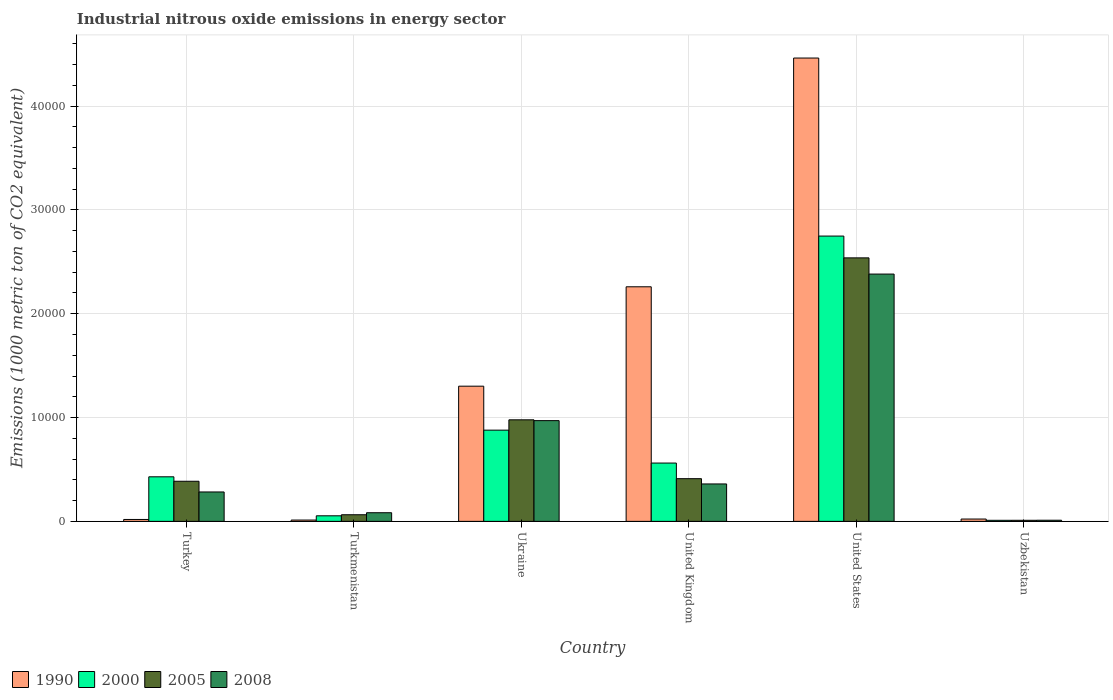How many different coloured bars are there?
Your answer should be very brief. 4. How many groups of bars are there?
Keep it short and to the point. 6. How many bars are there on the 6th tick from the right?
Provide a succinct answer. 4. What is the label of the 6th group of bars from the left?
Keep it short and to the point. Uzbekistan. In how many cases, is the number of bars for a given country not equal to the number of legend labels?
Provide a succinct answer. 0. What is the amount of industrial nitrous oxide emitted in 2000 in United States?
Your answer should be compact. 2.75e+04. Across all countries, what is the maximum amount of industrial nitrous oxide emitted in 2000?
Your response must be concise. 2.75e+04. Across all countries, what is the minimum amount of industrial nitrous oxide emitted in 2005?
Ensure brevity in your answer.  103.2. In which country was the amount of industrial nitrous oxide emitted in 2005 minimum?
Provide a short and direct response. Uzbekistan. What is the total amount of industrial nitrous oxide emitted in 2005 in the graph?
Make the answer very short. 4.39e+04. What is the difference between the amount of industrial nitrous oxide emitted in 2008 in Ukraine and that in United States?
Provide a succinct answer. -1.41e+04. What is the difference between the amount of industrial nitrous oxide emitted in 2005 in Ukraine and the amount of industrial nitrous oxide emitted in 1990 in United States?
Offer a very short reply. -3.48e+04. What is the average amount of industrial nitrous oxide emitted in 2000 per country?
Give a very brief answer. 7801.33. What is the difference between the amount of industrial nitrous oxide emitted of/in 1990 and amount of industrial nitrous oxide emitted of/in 2008 in Turkmenistan?
Your response must be concise. -706.9. What is the ratio of the amount of industrial nitrous oxide emitted in 2005 in United Kingdom to that in United States?
Give a very brief answer. 0.16. Is the amount of industrial nitrous oxide emitted in 2000 in Turkey less than that in Turkmenistan?
Keep it short and to the point. No. Is the difference between the amount of industrial nitrous oxide emitted in 1990 in Ukraine and United Kingdom greater than the difference between the amount of industrial nitrous oxide emitted in 2008 in Ukraine and United Kingdom?
Your answer should be very brief. No. What is the difference between the highest and the second highest amount of industrial nitrous oxide emitted in 2000?
Provide a succinct answer. -1.87e+04. What is the difference between the highest and the lowest amount of industrial nitrous oxide emitted in 1990?
Give a very brief answer. 4.45e+04. In how many countries, is the amount of industrial nitrous oxide emitted in 2000 greater than the average amount of industrial nitrous oxide emitted in 2000 taken over all countries?
Keep it short and to the point. 2. Is the sum of the amount of industrial nitrous oxide emitted in 2000 in Turkey and United Kingdom greater than the maximum amount of industrial nitrous oxide emitted in 2005 across all countries?
Ensure brevity in your answer.  No. Is it the case that in every country, the sum of the amount of industrial nitrous oxide emitted in 1990 and amount of industrial nitrous oxide emitted in 2008 is greater than the sum of amount of industrial nitrous oxide emitted in 2000 and amount of industrial nitrous oxide emitted in 2005?
Your answer should be compact. No. What does the 3rd bar from the left in Turkey represents?
Your response must be concise. 2005. Is it the case that in every country, the sum of the amount of industrial nitrous oxide emitted in 2000 and amount of industrial nitrous oxide emitted in 2005 is greater than the amount of industrial nitrous oxide emitted in 1990?
Your answer should be very brief. No. How many countries are there in the graph?
Offer a terse response. 6. Are the values on the major ticks of Y-axis written in scientific E-notation?
Keep it short and to the point. No. Does the graph contain any zero values?
Offer a very short reply. No. Does the graph contain grids?
Ensure brevity in your answer.  Yes. What is the title of the graph?
Your answer should be very brief. Industrial nitrous oxide emissions in energy sector. What is the label or title of the X-axis?
Make the answer very short. Country. What is the label or title of the Y-axis?
Your response must be concise. Emissions (1000 metric ton of CO2 equivalent). What is the Emissions (1000 metric ton of CO2 equivalent) in 1990 in Turkey?
Provide a short and direct response. 183.6. What is the Emissions (1000 metric ton of CO2 equivalent) in 2000 in Turkey?
Your response must be concise. 4292. What is the Emissions (1000 metric ton of CO2 equivalent) of 2005 in Turkey?
Keep it short and to the point. 3862.7. What is the Emissions (1000 metric ton of CO2 equivalent) of 2008 in Turkey?
Your answer should be very brief. 2831.3. What is the Emissions (1000 metric ton of CO2 equivalent) in 1990 in Turkmenistan?
Offer a terse response. 125.6. What is the Emissions (1000 metric ton of CO2 equivalent) in 2000 in Turkmenistan?
Offer a very short reply. 535.7. What is the Emissions (1000 metric ton of CO2 equivalent) in 2005 in Turkmenistan?
Your answer should be compact. 637.2. What is the Emissions (1000 metric ton of CO2 equivalent) in 2008 in Turkmenistan?
Keep it short and to the point. 832.5. What is the Emissions (1000 metric ton of CO2 equivalent) in 1990 in Ukraine?
Your answer should be compact. 1.30e+04. What is the Emissions (1000 metric ton of CO2 equivalent) of 2000 in Ukraine?
Your response must be concise. 8784.8. What is the Emissions (1000 metric ton of CO2 equivalent) in 2005 in Ukraine?
Offer a very short reply. 9779.9. What is the Emissions (1000 metric ton of CO2 equivalent) in 2008 in Ukraine?
Your answer should be very brief. 9701.8. What is the Emissions (1000 metric ton of CO2 equivalent) in 1990 in United Kingdom?
Keep it short and to the point. 2.26e+04. What is the Emissions (1000 metric ton of CO2 equivalent) of 2000 in United Kingdom?
Make the answer very short. 5616. What is the Emissions (1000 metric ton of CO2 equivalent) of 2005 in United Kingdom?
Make the answer very short. 4111.2. What is the Emissions (1000 metric ton of CO2 equivalent) of 2008 in United Kingdom?
Make the answer very short. 3604.6. What is the Emissions (1000 metric ton of CO2 equivalent) in 1990 in United States?
Offer a terse response. 4.46e+04. What is the Emissions (1000 metric ton of CO2 equivalent) in 2000 in United States?
Offer a terse response. 2.75e+04. What is the Emissions (1000 metric ton of CO2 equivalent) in 2005 in United States?
Your answer should be very brief. 2.54e+04. What is the Emissions (1000 metric ton of CO2 equivalent) in 2008 in United States?
Your answer should be very brief. 2.38e+04. What is the Emissions (1000 metric ton of CO2 equivalent) of 1990 in Uzbekistan?
Offer a very short reply. 223.2. What is the Emissions (1000 metric ton of CO2 equivalent) in 2000 in Uzbekistan?
Give a very brief answer. 101.6. What is the Emissions (1000 metric ton of CO2 equivalent) of 2005 in Uzbekistan?
Offer a terse response. 103.2. What is the Emissions (1000 metric ton of CO2 equivalent) in 2008 in Uzbekistan?
Give a very brief answer. 109.4. Across all countries, what is the maximum Emissions (1000 metric ton of CO2 equivalent) in 1990?
Your answer should be very brief. 4.46e+04. Across all countries, what is the maximum Emissions (1000 metric ton of CO2 equivalent) in 2000?
Make the answer very short. 2.75e+04. Across all countries, what is the maximum Emissions (1000 metric ton of CO2 equivalent) in 2005?
Provide a succinct answer. 2.54e+04. Across all countries, what is the maximum Emissions (1000 metric ton of CO2 equivalent) of 2008?
Ensure brevity in your answer.  2.38e+04. Across all countries, what is the minimum Emissions (1000 metric ton of CO2 equivalent) of 1990?
Provide a succinct answer. 125.6. Across all countries, what is the minimum Emissions (1000 metric ton of CO2 equivalent) in 2000?
Your answer should be compact. 101.6. Across all countries, what is the minimum Emissions (1000 metric ton of CO2 equivalent) of 2005?
Give a very brief answer. 103.2. Across all countries, what is the minimum Emissions (1000 metric ton of CO2 equivalent) of 2008?
Offer a very short reply. 109.4. What is the total Emissions (1000 metric ton of CO2 equivalent) of 1990 in the graph?
Your answer should be very brief. 8.08e+04. What is the total Emissions (1000 metric ton of CO2 equivalent) in 2000 in the graph?
Provide a short and direct response. 4.68e+04. What is the total Emissions (1000 metric ton of CO2 equivalent) in 2005 in the graph?
Offer a terse response. 4.39e+04. What is the total Emissions (1000 metric ton of CO2 equivalent) in 2008 in the graph?
Your answer should be very brief. 4.09e+04. What is the difference between the Emissions (1000 metric ton of CO2 equivalent) in 2000 in Turkey and that in Turkmenistan?
Your response must be concise. 3756.3. What is the difference between the Emissions (1000 metric ton of CO2 equivalent) in 2005 in Turkey and that in Turkmenistan?
Your response must be concise. 3225.5. What is the difference between the Emissions (1000 metric ton of CO2 equivalent) in 2008 in Turkey and that in Turkmenistan?
Ensure brevity in your answer.  1998.8. What is the difference between the Emissions (1000 metric ton of CO2 equivalent) of 1990 in Turkey and that in Ukraine?
Your answer should be compact. -1.28e+04. What is the difference between the Emissions (1000 metric ton of CO2 equivalent) of 2000 in Turkey and that in Ukraine?
Your answer should be compact. -4492.8. What is the difference between the Emissions (1000 metric ton of CO2 equivalent) in 2005 in Turkey and that in Ukraine?
Keep it short and to the point. -5917.2. What is the difference between the Emissions (1000 metric ton of CO2 equivalent) of 2008 in Turkey and that in Ukraine?
Provide a succinct answer. -6870.5. What is the difference between the Emissions (1000 metric ton of CO2 equivalent) in 1990 in Turkey and that in United Kingdom?
Provide a short and direct response. -2.24e+04. What is the difference between the Emissions (1000 metric ton of CO2 equivalent) in 2000 in Turkey and that in United Kingdom?
Keep it short and to the point. -1324. What is the difference between the Emissions (1000 metric ton of CO2 equivalent) of 2005 in Turkey and that in United Kingdom?
Your answer should be very brief. -248.5. What is the difference between the Emissions (1000 metric ton of CO2 equivalent) of 2008 in Turkey and that in United Kingdom?
Offer a very short reply. -773.3. What is the difference between the Emissions (1000 metric ton of CO2 equivalent) of 1990 in Turkey and that in United States?
Offer a very short reply. -4.44e+04. What is the difference between the Emissions (1000 metric ton of CO2 equivalent) in 2000 in Turkey and that in United States?
Keep it short and to the point. -2.32e+04. What is the difference between the Emissions (1000 metric ton of CO2 equivalent) in 2005 in Turkey and that in United States?
Offer a very short reply. -2.15e+04. What is the difference between the Emissions (1000 metric ton of CO2 equivalent) of 2008 in Turkey and that in United States?
Give a very brief answer. -2.10e+04. What is the difference between the Emissions (1000 metric ton of CO2 equivalent) in 1990 in Turkey and that in Uzbekistan?
Give a very brief answer. -39.6. What is the difference between the Emissions (1000 metric ton of CO2 equivalent) in 2000 in Turkey and that in Uzbekistan?
Keep it short and to the point. 4190.4. What is the difference between the Emissions (1000 metric ton of CO2 equivalent) in 2005 in Turkey and that in Uzbekistan?
Offer a terse response. 3759.5. What is the difference between the Emissions (1000 metric ton of CO2 equivalent) in 2008 in Turkey and that in Uzbekistan?
Give a very brief answer. 2721.9. What is the difference between the Emissions (1000 metric ton of CO2 equivalent) of 1990 in Turkmenistan and that in Ukraine?
Provide a short and direct response. -1.29e+04. What is the difference between the Emissions (1000 metric ton of CO2 equivalent) in 2000 in Turkmenistan and that in Ukraine?
Your answer should be compact. -8249.1. What is the difference between the Emissions (1000 metric ton of CO2 equivalent) in 2005 in Turkmenistan and that in Ukraine?
Ensure brevity in your answer.  -9142.7. What is the difference between the Emissions (1000 metric ton of CO2 equivalent) of 2008 in Turkmenistan and that in Ukraine?
Your response must be concise. -8869.3. What is the difference between the Emissions (1000 metric ton of CO2 equivalent) of 1990 in Turkmenistan and that in United Kingdom?
Ensure brevity in your answer.  -2.25e+04. What is the difference between the Emissions (1000 metric ton of CO2 equivalent) of 2000 in Turkmenistan and that in United Kingdom?
Make the answer very short. -5080.3. What is the difference between the Emissions (1000 metric ton of CO2 equivalent) of 2005 in Turkmenistan and that in United Kingdom?
Ensure brevity in your answer.  -3474. What is the difference between the Emissions (1000 metric ton of CO2 equivalent) of 2008 in Turkmenistan and that in United Kingdom?
Make the answer very short. -2772.1. What is the difference between the Emissions (1000 metric ton of CO2 equivalent) of 1990 in Turkmenistan and that in United States?
Your answer should be compact. -4.45e+04. What is the difference between the Emissions (1000 metric ton of CO2 equivalent) of 2000 in Turkmenistan and that in United States?
Your answer should be very brief. -2.69e+04. What is the difference between the Emissions (1000 metric ton of CO2 equivalent) in 2005 in Turkmenistan and that in United States?
Provide a succinct answer. -2.47e+04. What is the difference between the Emissions (1000 metric ton of CO2 equivalent) in 2008 in Turkmenistan and that in United States?
Offer a terse response. -2.30e+04. What is the difference between the Emissions (1000 metric ton of CO2 equivalent) of 1990 in Turkmenistan and that in Uzbekistan?
Give a very brief answer. -97.6. What is the difference between the Emissions (1000 metric ton of CO2 equivalent) in 2000 in Turkmenistan and that in Uzbekistan?
Provide a succinct answer. 434.1. What is the difference between the Emissions (1000 metric ton of CO2 equivalent) in 2005 in Turkmenistan and that in Uzbekistan?
Keep it short and to the point. 534. What is the difference between the Emissions (1000 metric ton of CO2 equivalent) of 2008 in Turkmenistan and that in Uzbekistan?
Offer a terse response. 723.1. What is the difference between the Emissions (1000 metric ton of CO2 equivalent) of 1990 in Ukraine and that in United Kingdom?
Your response must be concise. -9573. What is the difference between the Emissions (1000 metric ton of CO2 equivalent) of 2000 in Ukraine and that in United Kingdom?
Your answer should be compact. 3168.8. What is the difference between the Emissions (1000 metric ton of CO2 equivalent) of 2005 in Ukraine and that in United Kingdom?
Give a very brief answer. 5668.7. What is the difference between the Emissions (1000 metric ton of CO2 equivalent) in 2008 in Ukraine and that in United Kingdom?
Your response must be concise. 6097.2. What is the difference between the Emissions (1000 metric ton of CO2 equivalent) of 1990 in Ukraine and that in United States?
Offer a terse response. -3.16e+04. What is the difference between the Emissions (1000 metric ton of CO2 equivalent) of 2000 in Ukraine and that in United States?
Your answer should be very brief. -1.87e+04. What is the difference between the Emissions (1000 metric ton of CO2 equivalent) of 2005 in Ukraine and that in United States?
Offer a terse response. -1.56e+04. What is the difference between the Emissions (1000 metric ton of CO2 equivalent) of 2008 in Ukraine and that in United States?
Keep it short and to the point. -1.41e+04. What is the difference between the Emissions (1000 metric ton of CO2 equivalent) of 1990 in Ukraine and that in Uzbekistan?
Provide a succinct answer. 1.28e+04. What is the difference between the Emissions (1000 metric ton of CO2 equivalent) in 2000 in Ukraine and that in Uzbekistan?
Offer a very short reply. 8683.2. What is the difference between the Emissions (1000 metric ton of CO2 equivalent) of 2005 in Ukraine and that in Uzbekistan?
Your answer should be compact. 9676.7. What is the difference between the Emissions (1000 metric ton of CO2 equivalent) in 2008 in Ukraine and that in Uzbekistan?
Your response must be concise. 9592.4. What is the difference between the Emissions (1000 metric ton of CO2 equivalent) of 1990 in United Kingdom and that in United States?
Your response must be concise. -2.20e+04. What is the difference between the Emissions (1000 metric ton of CO2 equivalent) of 2000 in United Kingdom and that in United States?
Offer a very short reply. -2.19e+04. What is the difference between the Emissions (1000 metric ton of CO2 equivalent) in 2005 in United Kingdom and that in United States?
Provide a succinct answer. -2.13e+04. What is the difference between the Emissions (1000 metric ton of CO2 equivalent) of 2008 in United Kingdom and that in United States?
Make the answer very short. -2.02e+04. What is the difference between the Emissions (1000 metric ton of CO2 equivalent) in 1990 in United Kingdom and that in Uzbekistan?
Provide a short and direct response. 2.24e+04. What is the difference between the Emissions (1000 metric ton of CO2 equivalent) in 2000 in United Kingdom and that in Uzbekistan?
Offer a terse response. 5514.4. What is the difference between the Emissions (1000 metric ton of CO2 equivalent) in 2005 in United Kingdom and that in Uzbekistan?
Make the answer very short. 4008. What is the difference between the Emissions (1000 metric ton of CO2 equivalent) of 2008 in United Kingdom and that in Uzbekistan?
Offer a very short reply. 3495.2. What is the difference between the Emissions (1000 metric ton of CO2 equivalent) in 1990 in United States and that in Uzbekistan?
Offer a terse response. 4.44e+04. What is the difference between the Emissions (1000 metric ton of CO2 equivalent) of 2000 in United States and that in Uzbekistan?
Provide a succinct answer. 2.74e+04. What is the difference between the Emissions (1000 metric ton of CO2 equivalent) in 2005 in United States and that in Uzbekistan?
Keep it short and to the point. 2.53e+04. What is the difference between the Emissions (1000 metric ton of CO2 equivalent) in 2008 in United States and that in Uzbekistan?
Give a very brief answer. 2.37e+04. What is the difference between the Emissions (1000 metric ton of CO2 equivalent) of 1990 in Turkey and the Emissions (1000 metric ton of CO2 equivalent) of 2000 in Turkmenistan?
Give a very brief answer. -352.1. What is the difference between the Emissions (1000 metric ton of CO2 equivalent) in 1990 in Turkey and the Emissions (1000 metric ton of CO2 equivalent) in 2005 in Turkmenistan?
Ensure brevity in your answer.  -453.6. What is the difference between the Emissions (1000 metric ton of CO2 equivalent) of 1990 in Turkey and the Emissions (1000 metric ton of CO2 equivalent) of 2008 in Turkmenistan?
Provide a short and direct response. -648.9. What is the difference between the Emissions (1000 metric ton of CO2 equivalent) in 2000 in Turkey and the Emissions (1000 metric ton of CO2 equivalent) in 2005 in Turkmenistan?
Keep it short and to the point. 3654.8. What is the difference between the Emissions (1000 metric ton of CO2 equivalent) of 2000 in Turkey and the Emissions (1000 metric ton of CO2 equivalent) of 2008 in Turkmenistan?
Give a very brief answer. 3459.5. What is the difference between the Emissions (1000 metric ton of CO2 equivalent) of 2005 in Turkey and the Emissions (1000 metric ton of CO2 equivalent) of 2008 in Turkmenistan?
Your answer should be very brief. 3030.2. What is the difference between the Emissions (1000 metric ton of CO2 equivalent) in 1990 in Turkey and the Emissions (1000 metric ton of CO2 equivalent) in 2000 in Ukraine?
Make the answer very short. -8601.2. What is the difference between the Emissions (1000 metric ton of CO2 equivalent) of 1990 in Turkey and the Emissions (1000 metric ton of CO2 equivalent) of 2005 in Ukraine?
Offer a very short reply. -9596.3. What is the difference between the Emissions (1000 metric ton of CO2 equivalent) of 1990 in Turkey and the Emissions (1000 metric ton of CO2 equivalent) of 2008 in Ukraine?
Your answer should be compact. -9518.2. What is the difference between the Emissions (1000 metric ton of CO2 equivalent) of 2000 in Turkey and the Emissions (1000 metric ton of CO2 equivalent) of 2005 in Ukraine?
Give a very brief answer. -5487.9. What is the difference between the Emissions (1000 metric ton of CO2 equivalent) of 2000 in Turkey and the Emissions (1000 metric ton of CO2 equivalent) of 2008 in Ukraine?
Ensure brevity in your answer.  -5409.8. What is the difference between the Emissions (1000 metric ton of CO2 equivalent) in 2005 in Turkey and the Emissions (1000 metric ton of CO2 equivalent) in 2008 in Ukraine?
Keep it short and to the point. -5839.1. What is the difference between the Emissions (1000 metric ton of CO2 equivalent) in 1990 in Turkey and the Emissions (1000 metric ton of CO2 equivalent) in 2000 in United Kingdom?
Your answer should be very brief. -5432.4. What is the difference between the Emissions (1000 metric ton of CO2 equivalent) of 1990 in Turkey and the Emissions (1000 metric ton of CO2 equivalent) of 2005 in United Kingdom?
Provide a succinct answer. -3927.6. What is the difference between the Emissions (1000 metric ton of CO2 equivalent) in 1990 in Turkey and the Emissions (1000 metric ton of CO2 equivalent) in 2008 in United Kingdom?
Make the answer very short. -3421. What is the difference between the Emissions (1000 metric ton of CO2 equivalent) of 2000 in Turkey and the Emissions (1000 metric ton of CO2 equivalent) of 2005 in United Kingdom?
Ensure brevity in your answer.  180.8. What is the difference between the Emissions (1000 metric ton of CO2 equivalent) in 2000 in Turkey and the Emissions (1000 metric ton of CO2 equivalent) in 2008 in United Kingdom?
Keep it short and to the point. 687.4. What is the difference between the Emissions (1000 metric ton of CO2 equivalent) of 2005 in Turkey and the Emissions (1000 metric ton of CO2 equivalent) of 2008 in United Kingdom?
Ensure brevity in your answer.  258.1. What is the difference between the Emissions (1000 metric ton of CO2 equivalent) of 1990 in Turkey and the Emissions (1000 metric ton of CO2 equivalent) of 2000 in United States?
Ensure brevity in your answer.  -2.73e+04. What is the difference between the Emissions (1000 metric ton of CO2 equivalent) of 1990 in Turkey and the Emissions (1000 metric ton of CO2 equivalent) of 2005 in United States?
Make the answer very short. -2.52e+04. What is the difference between the Emissions (1000 metric ton of CO2 equivalent) of 1990 in Turkey and the Emissions (1000 metric ton of CO2 equivalent) of 2008 in United States?
Offer a terse response. -2.36e+04. What is the difference between the Emissions (1000 metric ton of CO2 equivalent) of 2000 in Turkey and the Emissions (1000 metric ton of CO2 equivalent) of 2005 in United States?
Ensure brevity in your answer.  -2.11e+04. What is the difference between the Emissions (1000 metric ton of CO2 equivalent) in 2000 in Turkey and the Emissions (1000 metric ton of CO2 equivalent) in 2008 in United States?
Give a very brief answer. -1.95e+04. What is the difference between the Emissions (1000 metric ton of CO2 equivalent) in 2005 in Turkey and the Emissions (1000 metric ton of CO2 equivalent) in 2008 in United States?
Keep it short and to the point. -2.00e+04. What is the difference between the Emissions (1000 metric ton of CO2 equivalent) of 1990 in Turkey and the Emissions (1000 metric ton of CO2 equivalent) of 2000 in Uzbekistan?
Your answer should be very brief. 82. What is the difference between the Emissions (1000 metric ton of CO2 equivalent) of 1990 in Turkey and the Emissions (1000 metric ton of CO2 equivalent) of 2005 in Uzbekistan?
Provide a succinct answer. 80.4. What is the difference between the Emissions (1000 metric ton of CO2 equivalent) in 1990 in Turkey and the Emissions (1000 metric ton of CO2 equivalent) in 2008 in Uzbekistan?
Make the answer very short. 74.2. What is the difference between the Emissions (1000 metric ton of CO2 equivalent) of 2000 in Turkey and the Emissions (1000 metric ton of CO2 equivalent) of 2005 in Uzbekistan?
Provide a succinct answer. 4188.8. What is the difference between the Emissions (1000 metric ton of CO2 equivalent) of 2000 in Turkey and the Emissions (1000 metric ton of CO2 equivalent) of 2008 in Uzbekistan?
Provide a succinct answer. 4182.6. What is the difference between the Emissions (1000 metric ton of CO2 equivalent) of 2005 in Turkey and the Emissions (1000 metric ton of CO2 equivalent) of 2008 in Uzbekistan?
Make the answer very short. 3753.3. What is the difference between the Emissions (1000 metric ton of CO2 equivalent) of 1990 in Turkmenistan and the Emissions (1000 metric ton of CO2 equivalent) of 2000 in Ukraine?
Your response must be concise. -8659.2. What is the difference between the Emissions (1000 metric ton of CO2 equivalent) in 1990 in Turkmenistan and the Emissions (1000 metric ton of CO2 equivalent) in 2005 in Ukraine?
Offer a terse response. -9654.3. What is the difference between the Emissions (1000 metric ton of CO2 equivalent) in 1990 in Turkmenistan and the Emissions (1000 metric ton of CO2 equivalent) in 2008 in Ukraine?
Make the answer very short. -9576.2. What is the difference between the Emissions (1000 metric ton of CO2 equivalent) of 2000 in Turkmenistan and the Emissions (1000 metric ton of CO2 equivalent) of 2005 in Ukraine?
Give a very brief answer. -9244.2. What is the difference between the Emissions (1000 metric ton of CO2 equivalent) in 2000 in Turkmenistan and the Emissions (1000 metric ton of CO2 equivalent) in 2008 in Ukraine?
Give a very brief answer. -9166.1. What is the difference between the Emissions (1000 metric ton of CO2 equivalent) in 2005 in Turkmenistan and the Emissions (1000 metric ton of CO2 equivalent) in 2008 in Ukraine?
Your response must be concise. -9064.6. What is the difference between the Emissions (1000 metric ton of CO2 equivalent) of 1990 in Turkmenistan and the Emissions (1000 metric ton of CO2 equivalent) of 2000 in United Kingdom?
Your answer should be very brief. -5490.4. What is the difference between the Emissions (1000 metric ton of CO2 equivalent) of 1990 in Turkmenistan and the Emissions (1000 metric ton of CO2 equivalent) of 2005 in United Kingdom?
Your answer should be compact. -3985.6. What is the difference between the Emissions (1000 metric ton of CO2 equivalent) of 1990 in Turkmenistan and the Emissions (1000 metric ton of CO2 equivalent) of 2008 in United Kingdom?
Make the answer very short. -3479. What is the difference between the Emissions (1000 metric ton of CO2 equivalent) of 2000 in Turkmenistan and the Emissions (1000 metric ton of CO2 equivalent) of 2005 in United Kingdom?
Keep it short and to the point. -3575.5. What is the difference between the Emissions (1000 metric ton of CO2 equivalent) in 2000 in Turkmenistan and the Emissions (1000 metric ton of CO2 equivalent) in 2008 in United Kingdom?
Your answer should be compact. -3068.9. What is the difference between the Emissions (1000 metric ton of CO2 equivalent) of 2005 in Turkmenistan and the Emissions (1000 metric ton of CO2 equivalent) of 2008 in United Kingdom?
Ensure brevity in your answer.  -2967.4. What is the difference between the Emissions (1000 metric ton of CO2 equivalent) of 1990 in Turkmenistan and the Emissions (1000 metric ton of CO2 equivalent) of 2000 in United States?
Offer a very short reply. -2.74e+04. What is the difference between the Emissions (1000 metric ton of CO2 equivalent) of 1990 in Turkmenistan and the Emissions (1000 metric ton of CO2 equivalent) of 2005 in United States?
Provide a succinct answer. -2.53e+04. What is the difference between the Emissions (1000 metric ton of CO2 equivalent) in 1990 in Turkmenistan and the Emissions (1000 metric ton of CO2 equivalent) in 2008 in United States?
Make the answer very short. -2.37e+04. What is the difference between the Emissions (1000 metric ton of CO2 equivalent) in 2000 in Turkmenistan and the Emissions (1000 metric ton of CO2 equivalent) in 2005 in United States?
Make the answer very short. -2.48e+04. What is the difference between the Emissions (1000 metric ton of CO2 equivalent) in 2000 in Turkmenistan and the Emissions (1000 metric ton of CO2 equivalent) in 2008 in United States?
Offer a very short reply. -2.33e+04. What is the difference between the Emissions (1000 metric ton of CO2 equivalent) of 2005 in Turkmenistan and the Emissions (1000 metric ton of CO2 equivalent) of 2008 in United States?
Offer a very short reply. -2.32e+04. What is the difference between the Emissions (1000 metric ton of CO2 equivalent) in 1990 in Turkmenistan and the Emissions (1000 metric ton of CO2 equivalent) in 2005 in Uzbekistan?
Make the answer very short. 22.4. What is the difference between the Emissions (1000 metric ton of CO2 equivalent) of 2000 in Turkmenistan and the Emissions (1000 metric ton of CO2 equivalent) of 2005 in Uzbekistan?
Offer a very short reply. 432.5. What is the difference between the Emissions (1000 metric ton of CO2 equivalent) in 2000 in Turkmenistan and the Emissions (1000 metric ton of CO2 equivalent) in 2008 in Uzbekistan?
Provide a succinct answer. 426.3. What is the difference between the Emissions (1000 metric ton of CO2 equivalent) in 2005 in Turkmenistan and the Emissions (1000 metric ton of CO2 equivalent) in 2008 in Uzbekistan?
Make the answer very short. 527.8. What is the difference between the Emissions (1000 metric ton of CO2 equivalent) of 1990 in Ukraine and the Emissions (1000 metric ton of CO2 equivalent) of 2000 in United Kingdom?
Keep it short and to the point. 7404. What is the difference between the Emissions (1000 metric ton of CO2 equivalent) of 1990 in Ukraine and the Emissions (1000 metric ton of CO2 equivalent) of 2005 in United Kingdom?
Give a very brief answer. 8908.8. What is the difference between the Emissions (1000 metric ton of CO2 equivalent) in 1990 in Ukraine and the Emissions (1000 metric ton of CO2 equivalent) in 2008 in United Kingdom?
Provide a succinct answer. 9415.4. What is the difference between the Emissions (1000 metric ton of CO2 equivalent) in 2000 in Ukraine and the Emissions (1000 metric ton of CO2 equivalent) in 2005 in United Kingdom?
Make the answer very short. 4673.6. What is the difference between the Emissions (1000 metric ton of CO2 equivalent) of 2000 in Ukraine and the Emissions (1000 metric ton of CO2 equivalent) of 2008 in United Kingdom?
Give a very brief answer. 5180.2. What is the difference between the Emissions (1000 metric ton of CO2 equivalent) in 2005 in Ukraine and the Emissions (1000 metric ton of CO2 equivalent) in 2008 in United Kingdom?
Keep it short and to the point. 6175.3. What is the difference between the Emissions (1000 metric ton of CO2 equivalent) of 1990 in Ukraine and the Emissions (1000 metric ton of CO2 equivalent) of 2000 in United States?
Make the answer very short. -1.45e+04. What is the difference between the Emissions (1000 metric ton of CO2 equivalent) in 1990 in Ukraine and the Emissions (1000 metric ton of CO2 equivalent) in 2005 in United States?
Your answer should be compact. -1.24e+04. What is the difference between the Emissions (1000 metric ton of CO2 equivalent) of 1990 in Ukraine and the Emissions (1000 metric ton of CO2 equivalent) of 2008 in United States?
Offer a terse response. -1.08e+04. What is the difference between the Emissions (1000 metric ton of CO2 equivalent) in 2000 in Ukraine and the Emissions (1000 metric ton of CO2 equivalent) in 2005 in United States?
Make the answer very short. -1.66e+04. What is the difference between the Emissions (1000 metric ton of CO2 equivalent) in 2000 in Ukraine and the Emissions (1000 metric ton of CO2 equivalent) in 2008 in United States?
Provide a short and direct response. -1.50e+04. What is the difference between the Emissions (1000 metric ton of CO2 equivalent) in 2005 in Ukraine and the Emissions (1000 metric ton of CO2 equivalent) in 2008 in United States?
Provide a succinct answer. -1.40e+04. What is the difference between the Emissions (1000 metric ton of CO2 equivalent) in 1990 in Ukraine and the Emissions (1000 metric ton of CO2 equivalent) in 2000 in Uzbekistan?
Make the answer very short. 1.29e+04. What is the difference between the Emissions (1000 metric ton of CO2 equivalent) in 1990 in Ukraine and the Emissions (1000 metric ton of CO2 equivalent) in 2005 in Uzbekistan?
Offer a terse response. 1.29e+04. What is the difference between the Emissions (1000 metric ton of CO2 equivalent) in 1990 in Ukraine and the Emissions (1000 metric ton of CO2 equivalent) in 2008 in Uzbekistan?
Make the answer very short. 1.29e+04. What is the difference between the Emissions (1000 metric ton of CO2 equivalent) in 2000 in Ukraine and the Emissions (1000 metric ton of CO2 equivalent) in 2005 in Uzbekistan?
Provide a succinct answer. 8681.6. What is the difference between the Emissions (1000 metric ton of CO2 equivalent) in 2000 in Ukraine and the Emissions (1000 metric ton of CO2 equivalent) in 2008 in Uzbekistan?
Your response must be concise. 8675.4. What is the difference between the Emissions (1000 metric ton of CO2 equivalent) of 2005 in Ukraine and the Emissions (1000 metric ton of CO2 equivalent) of 2008 in Uzbekistan?
Provide a succinct answer. 9670.5. What is the difference between the Emissions (1000 metric ton of CO2 equivalent) of 1990 in United Kingdom and the Emissions (1000 metric ton of CO2 equivalent) of 2000 in United States?
Provide a succinct answer. -4884.9. What is the difference between the Emissions (1000 metric ton of CO2 equivalent) of 1990 in United Kingdom and the Emissions (1000 metric ton of CO2 equivalent) of 2005 in United States?
Provide a succinct answer. -2785.7. What is the difference between the Emissions (1000 metric ton of CO2 equivalent) of 1990 in United Kingdom and the Emissions (1000 metric ton of CO2 equivalent) of 2008 in United States?
Make the answer very short. -1224.8. What is the difference between the Emissions (1000 metric ton of CO2 equivalent) in 2000 in United Kingdom and the Emissions (1000 metric ton of CO2 equivalent) in 2005 in United States?
Ensure brevity in your answer.  -1.98e+04. What is the difference between the Emissions (1000 metric ton of CO2 equivalent) of 2000 in United Kingdom and the Emissions (1000 metric ton of CO2 equivalent) of 2008 in United States?
Keep it short and to the point. -1.82e+04. What is the difference between the Emissions (1000 metric ton of CO2 equivalent) of 2005 in United Kingdom and the Emissions (1000 metric ton of CO2 equivalent) of 2008 in United States?
Your answer should be compact. -1.97e+04. What is the difference between the Emissions (1000 metric ton of CO2 equivalent) in 1990 in United Kingdom and the Emissions (1000 metric ton of CO2 equivalent) in 2000 in Uzbekistan?
Your answer should be very brief. 2.25e+04. What is the difference between the Emissions (1000 metric ton of CO2 equivalent) in 1990 in United Kingdom and the Emissions (1000 metric ton of CO2 equivalent) in 2005 in Uzbekistan?
Your answer should be very brief. 2.25e+04. What is the difference between the Emissions (1000 metric ton of CO2 equivalent) in 1990 in United Kingdom and the Emissions (1000 metric ton of CO2 equivalent) in 2008 in Uzbekistan?
Make the answer very short. 2.25e+04. What is the difference between the Emissions (1000 metric ton of CO2 equivalent) in 2000 in United Kingdom and the Emissions (1000 metric ton of CO2 equivalent) in 2005 in Uzbekistan?
Give a very brief answer. 5512.8. What is the difference between the Emissions (1000 metric ton of CO2 equivalent) of 2000 in United Kingdom and the Emissions (1000 metric ton of CO2 equivalent) of 2008 in Uzbekistan?
Give a very brief answer. 5506.6. What is the difference between the Emissions (1000 metric ton of CO2 equivalent) of 2005 in United Kingdom and the Emissions (1000 metric ton of CO2 equivalent) of 2008 in Uzbekistan?
Provide a short and direct response. 4001.8. What is the difference between the Emissions (1000 metric ton of CO2 equivalent) in 1990 in United States and the Emissions (1000 metric ton of CO2 equivalent) in 2000 in Uzbekistan?
Give a very brief answer. 4.45e+04. What is the difference between the Emissions (1000 metric ton of CO2 equivalent) in 1990 in United States and the Emissions (1000 metric ton of CO2 equivalent) in 2005 in Uzbekistan?
Offer a terse response. 4.45e+04. What is the difference between the Emissions (1000 metric ton of CO2 equivalent) in 1990 in United States and the Emissions (1000 metric ton of CO2 equivalent) in 2008 in Uzbekistan?
Ensure brevity in your answer.  4.45e+04. What is the difference between the Emissions (1000 metric ton of CO2 equivalent) in 2000 in United States and the Emissions (1000 metric ton of CO2 equivalent) in 2005 in Uzbekistan?
Give a very brief answer. 2.74e+04. What is the difference between the Emissions (1000 metric ton of CO2 equivalent) in 2000 in United States and the Emissions (1000 metric ton of CO2 equivalent) in 2008 in Uzbekistan?
Keep it short and to the point. 2.74e+04. What is the difference between the Emissions (1000 metric ton of CO2 equivalent) of 2005 in United States and the Emissions (1000 metric ton of CO2 equivalent) of 2008 in Uzbekistan?
Your response must be concise. 2.53e+04. What is the average Emissions (1000 metric ton of CO2 equivalent) of 1990 per country?
Provide a succinct answer. 1.35e+04. What is the average Emissions (1000 metric ton of CO2 equivalent) in 2000 per country?
Provide a succinct answer. 7801.33. What is the average Emissions (1000 metric ton of CO2 equivalent) in 2005 per country?
Make the answer very short. 7312.15. What is the average Emissions (1000 metric ton of CO2 equivalent) in 2008 per country?
Offer a very short reply. 6816.23. What is the difference between the Emissions (1000 metric ton of CO2 equivalent) of 1990 and Emissions (1000 metric ton of CO2 equivalent) of 2000 in Turkey?
Your response must be concise. -4108.4. What is the difference between the Emissions (1000 metric ton of CO2 equivalent) in 1990 and Emissions (1000 metric ton of CO2 equivalent) in 2005 in Turkey?
Provide a short and direct response. -3679.1. What is the difference between the Emissions (1000 metric ton of CO2 equivalent) of 1990 and Emissions (1000 metric ton of CO2 equivalent) of 2008 in Turkey?
Give a very brief answer. -2647.7. What is the difference between the Emissions (1000 metric ton of CO2 equivalent) in 2000 and Emissions (1000 metric ton of CO2 equivalent) in 2005 in Turkey?
Your answer should be very brief. 429.3. What is the difference between the Emissions (1000 metric ton of CO2 equivalent) in 2000 and Emissions (1000 metric ton of CO2 equivalent) in 2008 in Turkey?
Offer a very short reply. 1460.7. What is the difference between the Emissions (1000 metric ton of CO2 equivalent) of 2005 and Emissions (1000 metric ton of CO2 equivalent) of 2008 in Turkey?
Give a very brief answer. 1031.4. What is the difference between the Emissions (1000 metric ton of CO2 equivalent) of 1990 and Emissions (1000 metric ton of CO2 equivalent) of 2000 in Turkmenistan?
Ensure brevity in your answer.  -410.1. What is the difference between the Emissions (1000 metric ton of CO2 equivalent) of 1990 and Emissions (1000 metric ton of CO2 equivalent) of 2005 in Turkmenistan?
Your response must be concise. -511.6. What is the difference between the Emissions (1000 metric ton of CO2 equivalent) in 1990 and Emissions (1000 metric ton of CO2 equivalent) in 2008 in Turkmenistan?
Make the answer very short. -706.9. What is the difference between the Emissions (1000 metric ton of CO2 equivalent) in 2000 and Emissions (1000 metric ton of CO2 equivalent) in 2005 in Turkmenistan?
Provide a succinct answer. -101.5. What is the difference between the Emissions (1000 metric ton of CO2 equivalent) of 2000 and Emissions (1000 metric ton of CO2 equivalent) of 2008 in Turkmenistan?
Offer a very short reply. -296.8. What is the difference between the Emissions (1000 metric ton of CO2 equivalent) of 2005 and Emissions (1000 metric ton of CO2 equivalent) of 2008 in Turkmenistan?
Provide a short and direct response. -195.3. What is the difference between the Emissions (1000 metric ton of CO2 equivalent) in 1990 and Emissions (1000 metric ton of CO2 equivalent) in 2000 in Ukraine?
Provide a short and direct response. 4235.2. What is the difference between the Emissions (1000 metric ton of CO2 equivalent) of 1990 and Emissions (1000 metric ton of CO2 equivalent) of 2005 in Ukraine?
Your response must be concise. 3240.1. What is the difference between the Emissions (1000 metric ton of CO2 equivalent) in 1990 and Emissions (1000 metric ton of CO2 equivalent) in 2008 in Ukraine?
Your answer should be compact. 3318.2. What is the difference between the Emissions (1000 metric ton of CO2 equivalent) of 2000 and Emissions (1000 metric ton of CO2 equivalent) of 2005 in Ukraine?
Keep it short and to the point. -995.1. What is the difference between the Emissions (1000 metric ton of CO2 equivalent) in 2000 and Emissions (1000 metric ton of CO2 equivalent) in 2008 in Ukraine?
Offer a terse response. -917. What is the difference between the Emissions (1000 metric ton of CO2 equivalent) in 2005 and Emissions (1000 metric ton of CO2 equivalent) in 2008 in Ukraine?
Keep it short and to the point. 78.1. What is the difference between the Emissions (1000 metric ton of CO2 equivalent) of 1990 and Emissions (1000 metric ton of CO2 equivalent) of 2000 in United Kingdom?
Keep it short and to the point. 1.70e+04. What is the difference between the Emissions (1000 metric ton of CO2 equivalent) of 1990 and Emissions (1000 metric ton of CO2 equivalent) of 2005 in United Kingdom?
Provide a short and direct response. 1.85e+04. What is the difference between the Emissions (1000 metric ton of CO2 equivalent) of 1990 and Emissions (1000 metric ton of CO2 equivalent) of 2008 in United Kingdom?
Make the answer very short. 1.90e+04. What is the difference between the Emissions (1000 metric ton of CO2 equivalent) of 2000 and Emissions (1000 metric ton of CO2 equivalent) of 2005 in United Kingdom?
Provide a short and direct response. 1504.8. What is the difference between the Emissions (1000 metric ton of CO2 equivalent) in 2000 and Emissions (1000 metric ton of CO2 equivalent) in 2008 in United Kingdom?
Provide a succinct answer. 2011.4. What is the difference between the Emissions (1000 metric ton of CO2 equivalent) of 2005 and Emissions (1000 metric ton of CO2 equivalent) of 2008 in United Kingdom?
Offer a terse response. 506.6. What is the difference between the Emissions (1000 metric ton of CO2 equivalent) in 1990 and Emissions (1000 metric ton of CO2 equivalent) in 2000 in United States?
Give a very brief answer. 1.71e+04. What is the difference between the Emissions (1000 metric ton of CO2 equivalent) of 1990 and Emissions (1000 metric ton of CO2 equivalent) of 2005 in United States?
Offer a very short reply. 1.92e+04. What is the difference between the Emissions (1000 metric ton of CO2 equivalent) of 1990 and Emissions (1000 metric ton of CO2 equivalent) of 2008 in United States?
Offer a terse response. 2.08e+04. What is the difference between the Emissions (1000 metric ton of CO2 equivalent) of 2000 and Emissions (1000 metric ton of CO2 equivalent) of 2005 in United States?
Offer a very short reply. 2099.2. What is the difference between the Emissions (1000 metric ton of CO2 equivalent) in 2000 and Emissions (1000 metric ton of CO2 equivalent) in 2008 in United States?
Make the answer very short. 3660.1. What is the difference between the Emissions (1000 metric ton of CO2 equivalent) of 2005 and Emissions (1000 metric ton of CO2 equivalent) of 2008 in United States?
Ensure brevity in your answer.  1560.9. What is the difference between the Emissions (1000 metric ton of CO2 equivalent) in 1990 and Emissions (1000 metric ton of CO2 equivalent) in 2000 in Uzbekistan?
Your answer should be compact. 121.6. What is the difference between the Emissions (1000 metric ton of CO2 equivalent) of 1990 and Emissions (1000 metric ton of CO2 equivalent) of 2005 in Uzbekistan?
Give a very brief answer. 120. What is the difference between the Emissions (1000 metric ton of CO2 equivalent) in 1990 and Emissions (1000 metric ton of CO2 equivalent) in 2008 in Uzbekistan?
Make the answer very short. 113.8. What is the difference between the Emissions (1000 metric ton of CO2 equivalent) of 2000 and Emissions (1000 metric ton of CO2 equivalent) of 2005 in Uzbekistan?
Provide a succinct answer. -1.6. What is the difference between the Emissions (1000 metric ton of CO2 equivalent) of 2000 and Emissions (1000 metric ton of CO2 equivalent) of 2008 in Uzbekistan?
Your response must be concise. -7.8. What is the difference between the Emissions (1000 metric ton of CO2 equivalent) in 2005 and Emissions (1000 metric ton of CO2 equivalent) in 2008 in Uzbekistan?
Your answer should be compact. -6.2. What is the ratio of the Emissions (1000 metric ton of CO2 equivalent) in 1990 in Turkey to that in Turkmenistan?
Keep it short and to the point. 1.46. What is the ratio of the Emissions (1000 metric ton of CO2 equivalent) in 2000 in Turkey to that in Turkmenistan?
Offer a terse response. 8.01. What is the ratio of the Emissions (1000 metric ton of CO2 equivalent) of 2005 in Turkey to that in Turkmenistan?
Make the answer very short. 6.06. What is the ratio of the Emissions (1000 metric ton of CO2 equivalent) in 2008 in Turkey to that in Turkmenistan?
Your response must be concise. 3.4. What is the ratio of the Emissions (1000 metric ton of CO2 equivalent) in 1990 in Turkey to that in Ukraine?
Make the answer very short. 0.01. What is the ratio of the Emissions (1000 metric ton of CO2 equivalent) of 2000 in Turkey to that in Ukraine?
Offer a very short reply. 0.49. What is the ratio of the Emissions (1000 metric ton of CO2 equivalent) in 2005 in Turkey to that in Ukraine?
Provide a short and direct response. 0.4. What is the ratio of the Emissions (1000 metric ton of CO2 equivalent) of 2008 in Turkey to that in Ukraine?
Your answer should be compact. 0.29. What is the ratio of the Emissions (1000 metric ton of CO2 equivalent) in 1990 in Turkey to that in United Kingdom?
Make the answer very short. 0.01. What is the ratio of the Emissions (1000 metric ton of CO2 equivalent) of 2000 in Turkey to that in United Kingdom?
Ensure brevity in your answer.  0.76. What is the ratio of the Emissions (1000 metric ton of CO2 equivalent) in 2005 in Turkey to that in United Kingdom?
Make the answer very short. 0.94. What is the ratio of the Emissions (1000 metric ton of CO2 equivalent) in 2008 in Turkey to that in United Kingdom?
Provide a succinct answer. 0.79. What is the ratio of the Emissions (1000 metric ton of CO2 equivalent) in 1990 in Turkey to that in United States?
Make the answer very short. 0. What is the ratio of the Emissions (1000 metric ton of CO2 equivalent) in 2000 in Turkey to that in United States?
Your answer should be very brief. 0.16. What is the ratio of the Emissions (1000 metric ton of CO2 equivalent) of 2005 in Turkey to that in United States?
Your answer should be very brief. 0.15. What is the ratio of the Emissions (1000 metric ton of CO2 equivalent) in 2008 in Turkey to that in United States?
Give a very brief answer. 0.12. What is the ratio of the Emissions (1000 metric ton of CO2 equivalent) of 1990 in Turkey to that in Uzbekistan?
Make the answer very short. 0.82. What is the ratio of the Emissions (1000 metric ton of CO2 equivalent) in 2000 in Turkey to that in Uzbekistan?
Provide a succinct answer. 42.24. What is the ratio of the Emissions (1000 metric ton of CO2 equivalent) of 2005 in Turkey to that in Uzbekistan?
Offer a very short reply. 37.43. What is the ratio of the Emissions (1000 metric ton of CO2 equivalent) in 2008 in Turkey to that in Uzbekistan?
Keep it short and to the point. 25.88. What is the ratio of the Emissions (1000 metric ton of CO2 equivalent) in 1990 in Turkmenistan to that in Ukraine?
Keep it short and to the point. 0.01. What is the ratio of the Emissions (1000 metric ton of CO2 equivalent) of 2000 in Turkmenistan to that in Ukraine?
Provide a short and direct response. 0.06. What is the ratio of the Emissions (1000 metric ton of CO2 equivalent) of 2005 in Turkmenistan to that in Ukraine?
Provide a short and direct response. 0.07. What is the ratio of the Emissions (1000 metric ton of CO2 equivalent) of 2008 in Turkmenistan to that in Ukraine?
Provide a succinct answer. 0.09. What is the ratio of the Emissions (1000 metric ton of CO2 equivalent) of 1990 in Turkmenistan to that in United Kingdom?
Offer a very short reply. 0.01. What is the ratio of the Emissions (1000 metric ton of CO2 equivalent) of 2000 in Turkmenistan to that in United Kingdom?
Offer a very short reply. 0.1. What is the ratio of the Emissions (1000 metric ton of CO2 equivalent) of 2005 in Turkmenistan to that in United Kingdom?
Provide a short and direct response. 0.15. What is the ratio of the Emissions (1000 metric ton of CO2 equivalent) of 2008 in Turkmenistan to that in United Kingdom?
Provide a short and direct response. 0.23. What is the ratio of the Emissions (1000 metric ton of CO2 equivalent) of 1990 in Turkmenistan to that in United States?
Offer a terse response. 0. What is the ratio of the Emissions (1000 metric ton of CO2 equivalent) in 2000 in Turkmenistan to that in United States?
Your response must be concise. 0.02. What is the ratio of the Emissions (1000 metric ton of CO2 equivalent) of 2005 in Turkmenistan to that in United States?
Provide a short and direct response. 0.03. What is the ratio of the Emissions (1000 metric ton of CO2 equivalent) in 2008 in Turkmenistan to that in United States?
Keep it short and to the point. 0.04. What is the ratio of the Emissions (1000 metric ton of CO2 equivalent) in 1990 in Turkmenistan to that in Uzbekistan?
Your response must be concise. 0.56. What is the ratio of the Emissions (1000 metric ton of CO2 equivalent) in 2000 in Turkmenistan to that in Uzbekistan?
Give a very brief answer. 5.27. What is the ratio of the Emissions (1000 metric ton of CO2 equivalent) in 2005 in Turkmenistan to that in Uzbekistan?
Offer a terse response. 6.17. What is the ratio of the Emissions (1000 metric ton of CO2 equivalent) in 2008 in Turkmenistan to that in Uzbekistan?
Your response must be concise. 7.61. What is the ratio of the Emissions (1000 metric ton of CO2 equivalent) of 1990 in Ukraine to that in United Kingdom?
Ensure brevity in your answer.  0.58. What is the ratio of the Emissions (1000 metric ton of CO2 equivalent) in 2000 in Ukraine to that in United Kingdom?
Give a very brief answer. 1.56. What is the ratio of the Emissions (1000 metric ton of CO2 equivalent) of 2005 in Ukraine to that in United Kingdom?
Make the answer very short. 2.38. What is the ratio of the Emissions (1000 metric ton of CO2 equivalent) of 2008 in Ukraine to that in United Kingdom?
Make the answer very short. 2.69. What is the ratio of the Emissions (1000 metric ton of CO2 equivalent) of 1990 in Ukraine to that in United States?
Offer a terse response. 0.29. What is the ratio of the Emissions (1000 metric ton of CO2 equivalent) in 2000 in Ukraine to that in United States?
Give a very brief answer. 0.32. What is the ratio of the Emissions (1000 metric ton of CO2 equivalent) in 2005 in Ukraine to that in United States?
Your answer should be very brief. 0.39. What is the ratio of the Emissions (1000 metric ton of CO2 equivalent) in 2008 in Ukraine to that in United States?
Your response must be concise. 0.41. What is the ratio of the Emissions (1000 metric ton of CO2 equivalent) in 1990 in Ukraine to that in Uzbekistan?
Keep it short and to the point. 58.33. What is the ratio of the Emissions (1000 metric ton of CO2 equivalent) in 2000 in Ukraine to that in Uzbekistan?
Give a very brief answer. 86.46. What is the ratio of the Emissions (1000 metric ton of CO2 equivalent) of 2005 in Ukraine to that in Uzbekistan?
Make the answer very short. 94.77. What is the ratio of the Emissions (1000 metric ton of CO2 equivalent) in 2008 in Ukraine to that in Uzbekistan?
Make the answer very short. 88.68. What is the ratio of the Emissions (1000 metric ton of CO2 equivalent) in 1990 in United Kingdom to that in United States?
Your response must be concise. 0.51. What is the ratio of the Emissions (1000 metric ton of CO2 equivalent) of 2000 in United Kingdom to that in United States?
Give a very brief answer. 0.2. What is the ratio of the Emissions (1000 metric ton of CO2 equivalent) in 2005 in United Kingdom to that in United States?
Keep it short and to the point. 0.16. What is the ratio of the Emissions (1000 metric ton of CO2 equivalent) of 2008 in United Kingdom to that in United States?
Provide a short and direct response. 0.15. What is the ratio of the Emissions (1000 metric ton of CO2 equivalent) in 1990 in United Kingdom to that in Uzbekistan?
Offer a terse response. 101.22. What is the ratio of the Emissions (1000 metric ton of CO2 equivalent) in 2000 in United Kingdom to that in Uzbekistan?
Keep it short and to the point. 55.28. What is the ratio of the Emissions (1000 metric ton of CO2 equivalent) of 2005 in United Kingdom to that in Uzbekistan?
Make the answer very short. 39.84. What is the ratio of the Emissions (1000 metric ton of CO2 equivalent) of 2008 in United Kingdom to that in Uzbekistan?
Your response must be concise. 32.95. What is the ratio of the Emissions (1000 metric ton of CO2 equivalent) in 1990 in United States to that in Uzbekistan?
Provide a short and direct response. 199.93. What is the ratio of the Emissions (1000 metric ton of CO2 equivalent) in 2000 in United States to that in Uzbekistan?
Keep it short and to the point. 270.45. What is the ratio of the Emissions (1000 metric ton of CO2 equivalent) in 2005 in United States to that in Uzbekistan?
Make the answer very short. 245.92. What is the ratio of the Emissions (1000 metric ton of CO2 equivalent) in 2008 in United States to that in Uzbekistan?
Provide a short and direct response. 217.71. What is the difference between the highest and the second highest Emissions (1000 metric ton of CO2 equivalent) in 1990?
Your answer should be very brief. 2.20e+04. What is the difference between the highest and the second highest Emissions (1000 metric ton of CO2 equivalent) of 2000?
Provide a succinct answer. 1.87e+04. What is the difference between the highest and the second highest Emissions (1000 metric ton of CO2 equivalent) of 2005?
Make the answer very short. 1.56e+04. What is the difference between the highest and the second highest Emissions (1000 metric ton of CO2 equivalent) of 2008?
Provide a short and direct response. 1.41e+04. What is the difference between the highest and the lowest Emissions (1000 metric ton of CO2 equivalent) of 1990?
Offer a terse response. 4.45e+04. What is the difference between the highest and the lowest Emissions (1000 metric ton of CO2 equivalent) of 2000?
Offer a very short reply. 2.74e+04. What is the difference between the highest and the lowest Emissions (1000 metric ton of CO2 equivalent) in 2005?
Your response must be concise. 2.53e+04. What is the difference between the highest and the lowest Emissions (1000 metric ton of CO2 equivalent) of 2008?
Ensure brevity in your answer.  2.37e+04. 